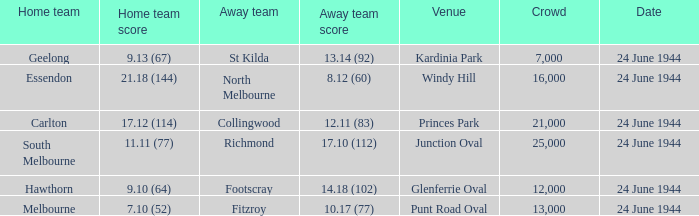When Essendon was the Home Team, what was the Away Team score? 8.12 (60). 